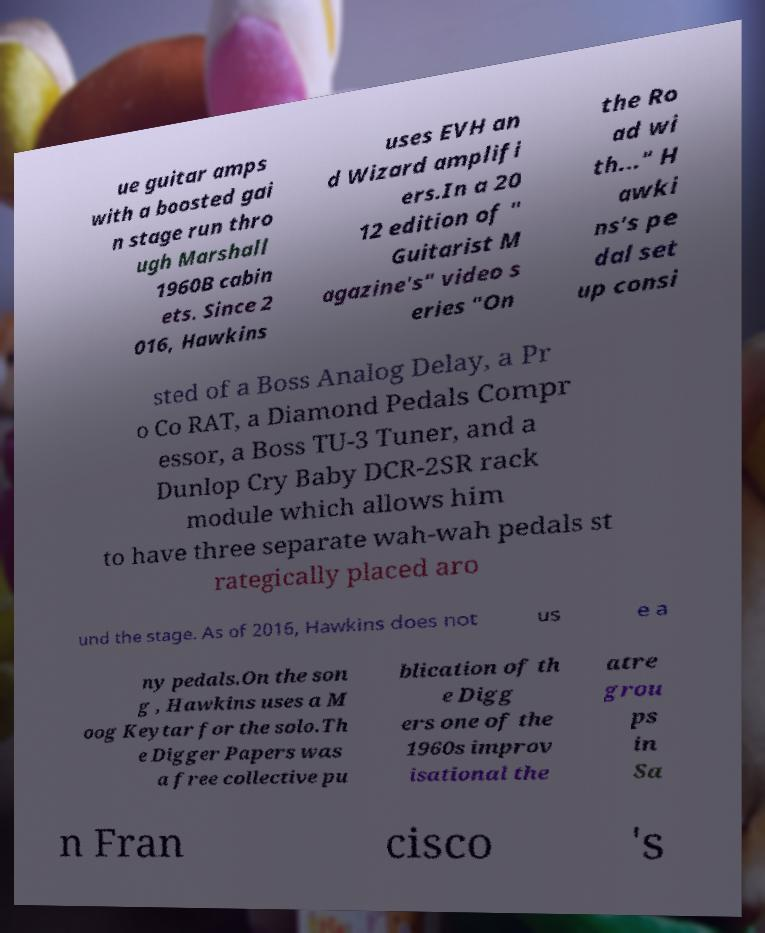What messages or text are displayed in this image? I need them in a readable, typed format. ue guitar amps with a boosted gai n stage run thro ugh Marshall 1960B cabin ets. Since 2 016, Hawkins uses EVH an d Wizard amplifi ers.In a 20 12 edition of " Guitarist M agazine's" video s eries "On the Ro ad wi th..." H awki ns's pe dal set up consi sted of a Boss Analog Delay, a Pr o Co RAT, a Diamond Pedals Compr essor, a Boss TU-3 Tuner, and a Dunlop Cry Baby DCR-2SR rack module which allows him to have three separate wah-wah pedals st rategically placed aro und the stage. As of 2016, Hawkins does not us e a ny pedals.On the son g , Hawkins uses a M oog Keytar for the solo.Th e Digger Papers was a free collective pu blication of th e Digg ers one of the 1960s improv isational the atre grou ps in Sa n Fran cisco 's 